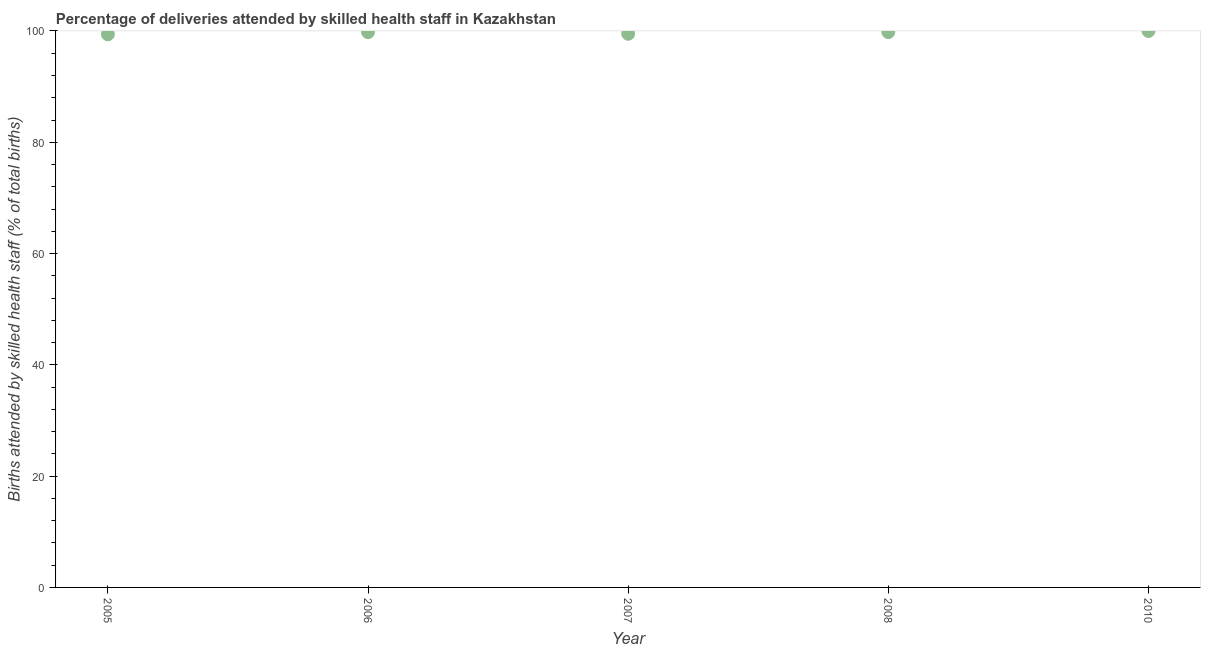What is the number of births attended by skilled health staff in 2006?
Provide a succinct answer. 99.8. Across all years, what is the minimum number of births attended by skilled health staff?
Ensure brevity in your answer.  99.4. In which year was the number of births attended by skilled health staff minimum?
Ensure brevity in your answer.  2005. What is the sum of the number of births attended by skilled health staff?
Your answer should be compact. 498.5. What is the difference between the number of births attended by skilled health staff in 2005 and 2008?
Offer a very short reply. -0.4. What is the average number of births attended by skilled health staff per year?
Make the answer very short. 99.7. What is the median number of births attended by skilled health staff?
Keep it short and to the point. 99.8. Do a majority of the years between 2006 and 2010 (inclusive) have number of births attended by skilled health staff greater than 52 %?
Ensure brevity in your answer.  Yes. What is the ratio of the number of births attended by skilled health staff in 2008 to that in 2010?
Your answer should be very brief. 1. What is the difference between the highest and the second highest number of births attended by skilled health staff?
Your answer should be compact. 0.2. What is the difference between the highest and the lowest number of births attended by skilled health staff?
Keep it short and to the point. 0.6. In how many years, is the number of births attended by skilled health staff greater than the average number of births attended by skilled health staff taken over all years?
Offer a terse response. 3. How many dotlines are there?
Your response must be concise. 1. Are the values on the major ticks of Y-axis written in scientific E-notation?
Your answer should be compact. No. What is the title of the graph?
Make the answer very short. Percentage of deliveries attended by skilled health staff in Kazakhstan. What is the label or title of the X-axis?
Make the answer very short. Year. What is the label or title of the Y-axis?
Keep it short and to the point. Births attended by skilled health staff (% of total births). What is the Births attended by skilled health staff (% of total births) in 2005?
Keep it short and to the point. 99.4. What is the Births attended by skilled health staff (% of total births) in 2006?
Provide a succinct answer. 99.8. What is the Births attended by skilled health staff (% of total births) in 2007?
Your answer should be compact. 99.5. What is the Births attended by skilled health staff (% of total births) in 2008?
Your answer should be compact. 99.8. What is the difference between the Births attended by skilled health staff (% of total births) in 2005 and 2008?
Your answer should be very brief. -0.4. What is the difference between the Births attended by skilled health staff (% of total births) in 2005 and 2010?
Provide a succinct answer. -0.6. What is the difference between the Births attended by skilled health staff (% of total births) in 2006 and 2010?
Offer a very short reply. -0.2. What is the ratio of the Births attended by skilled health staff (% of total births) in 2005 to that in 2008?
Provide a short and direct response. 1. What is the ratio of the Births attended by skilled health staff (% of total births) in 2006 to that in 2007?
Your answer should be compact. 1. What is the ratio of the Births attended by skilled health staff (% of total births) in 2007 to that in 2008?
Offer a terse response. 1. What is the ratio of the Births attended by skilled health staff (% of total births) in 2007 to that in 2010?
Your answer should be compact. 0.99. 